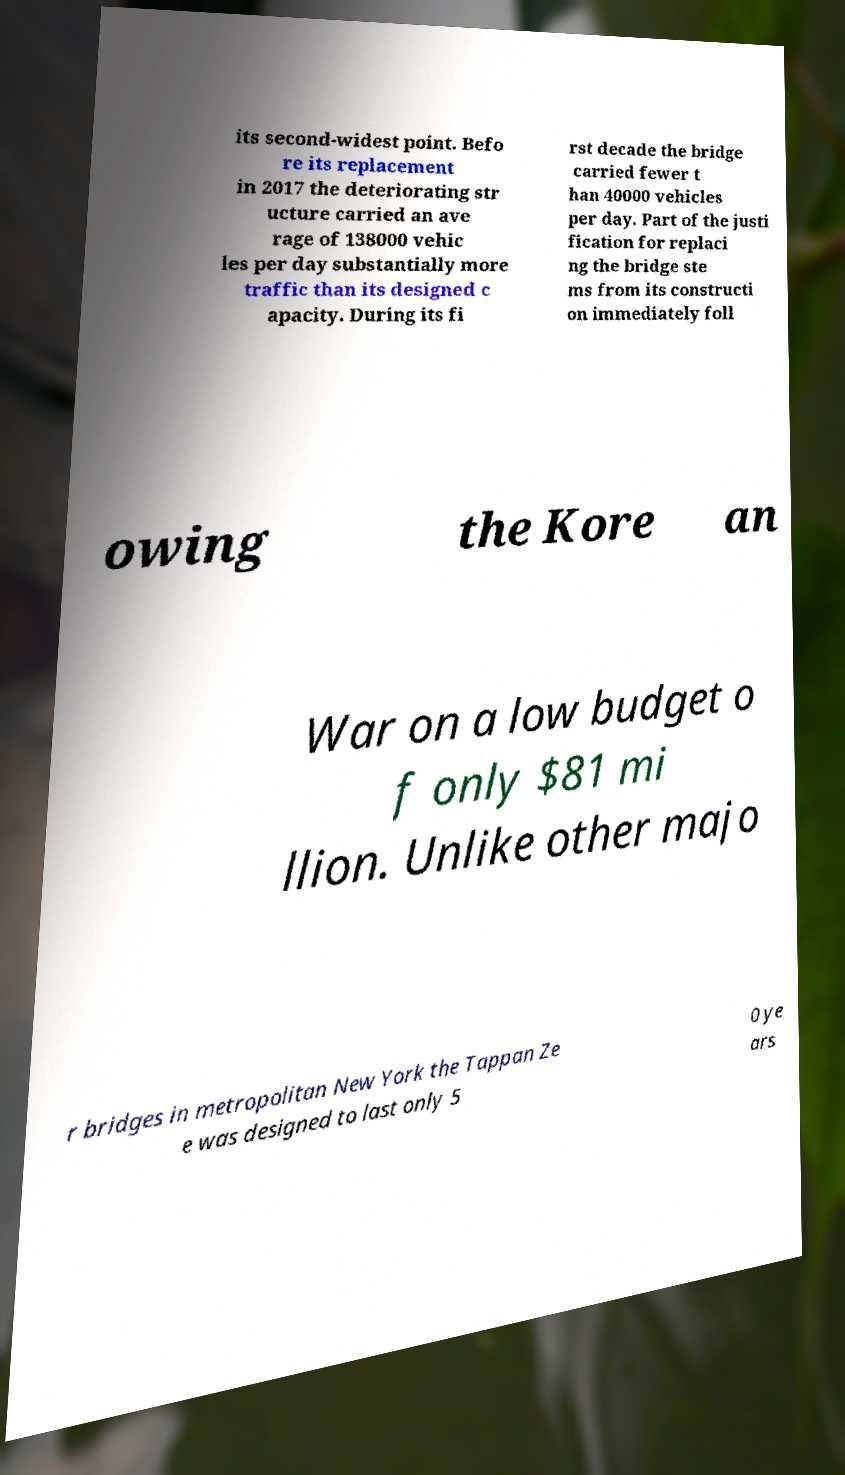Could you extract and type out the text from this image? its second-widest point. Befo re its replacement in 2017 the deteriorating str ucture carried an ave rage of 138000 vehic les per day substantially more traffic than its designed c apacity. During its fi rst decade the bridge carried fewer t han 40000 vehicles per day. Part of the justi fication for replaci ng the bridge ste ms from its constructi on immediately foll owing the Kore an War on a low budget o f only $81 mi llion. Unlike other majo r bridges in metropolitan New York the Tappan Ze e was designed to last only 5 0 ye ars 